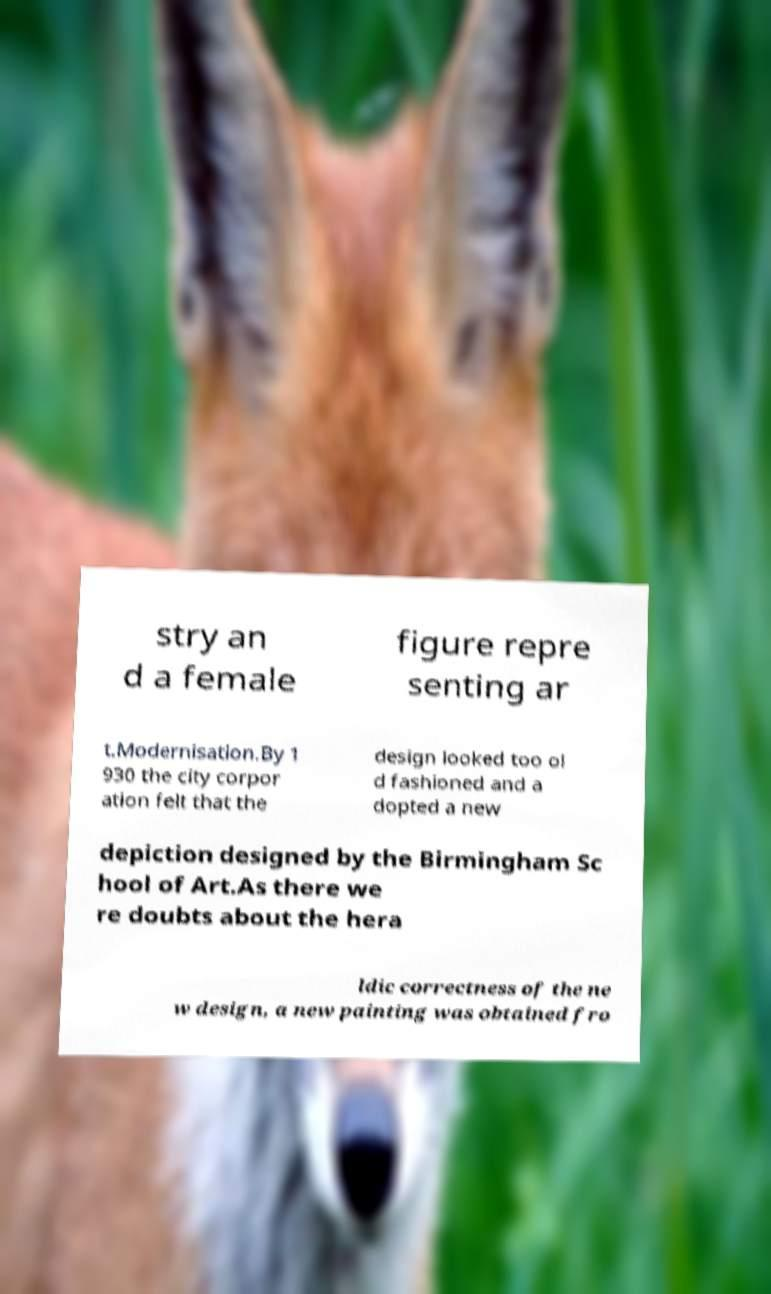Can you accurately transcribe the text from the provided image for me? stry an d a female figure repre senting ar t.Modernisation.By 1 930 the city corpor ation felt that the design looked too ol d fashioned and a dopted a new depiction designed by the Birmingham Sc hool of Art.As there we re doubts about the hera ldic correctness of the ne w design, a new painting was obtained fro 